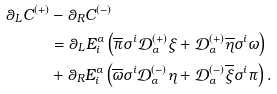<formula> <loc_0><loc_0><loc_500><loc_500>\theta _ { L } C ^ { ( + ) } & - \theta _ { R } C ^ { ( - ) } \\ & = \theta _ { L } E ^ { \alpha } _ { i } \left ( \overline { \pi } \sigma ^ { i } \mathcal { D } ^ { ( + ) } _ { \alpha } \xi + \mathcal { D } ^ { ( + ) } _ { \alpha } \overline { \eta } \sigma ^ { i } \omega \right ) \\ & + \theta _ { R } E ^ { \alpha } _ { i } \left ( \overline { \omega } \sigma ^ { i } \mathcal { D } ^ { ( - ) } _ { \alpha } \eta + \mathcal { D } ^ { ( - ) } _ { \alpha } \overline { \xi } \sigma ^ { i } \pi \right ) .</formula> 